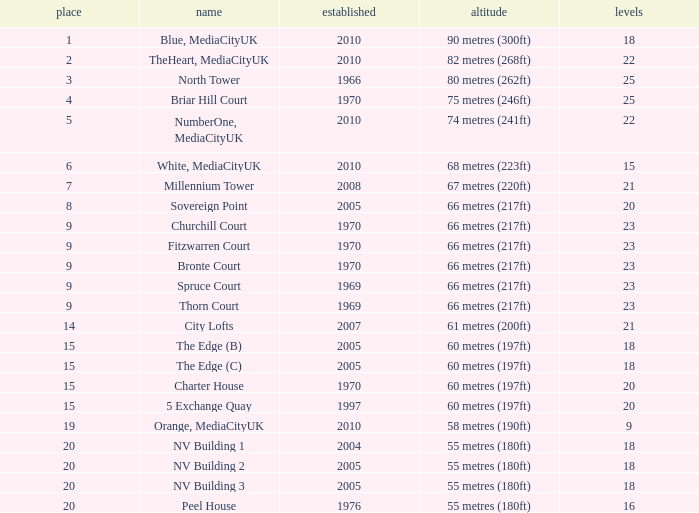What is the lowest Floors, when Built is greater than 1970, and when Name is NV Building 3? 18.0. 